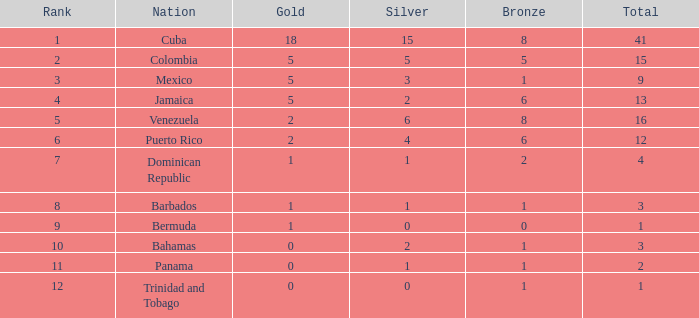Which Total is the lowest one that has a Rank smaller than 1? None. 